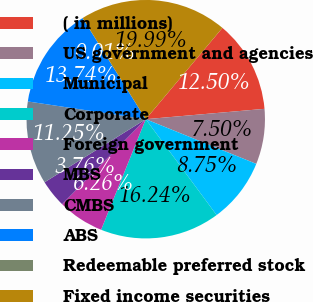Convert chart. <chart><loc_0><loc_0><loc_500><loc_500><pie_chart><fcel>( in millions)<fcel>US government and agencies<fcel>Municipal<fcel>Corporate<fcel>Foreign government<fcel>MBS<fcel>CMBS<fcel>ABS<fcel>Redeemable preferred stock<fcel>Fixed income securities<nl><fcel>12.5%<fcel>7.5%<fcel>8.75%<fcel>16.24%<fcel>6.26%<fcel>3.76%<fcel>11.25%<fcel>13.74%<fcel>0.01%<fcel>19.99%<nl></chart> 